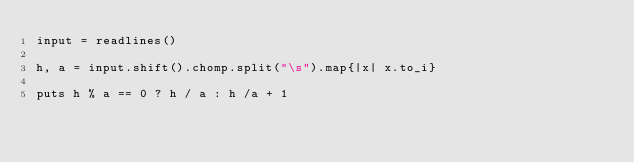<code> <loc_0><loc_0><loc_500><loc_500><_Ruby_>input = readlines()

h, a = input.shift().chomp.split("\s").map{|x| x.to_i}

puts h % a == 0 ? h / a : h /a + 1
</code> 